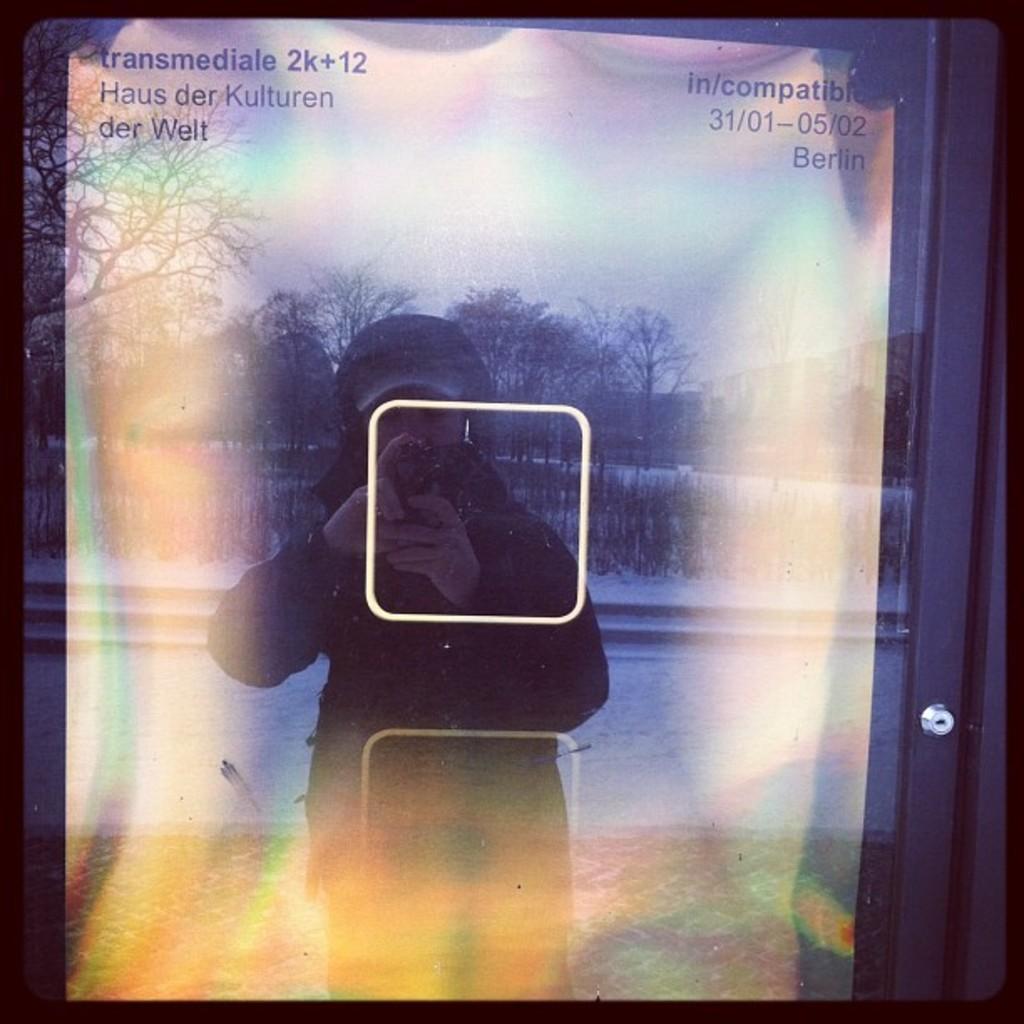Could you give a brief overview of what you see in this image? In this picture I can observe a glass door. In this glass door I can observe a reflection. In this reflection I can observe a person standing on the floor. In the background there are trees and sky. In the top of the picture I can observe some text. 